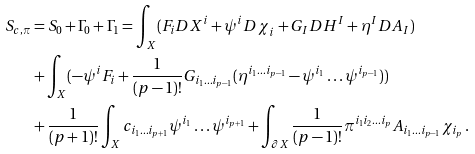<formula> <loc_0><loc_0><loc_500><loc_500>S _ { c , \pi } & = S _ { 0 } + \Gamma _ { 0 } + \Gamma _ { 1 } = \int _ { X } ( { F } _ { i } { D X } ^ { i } + { \psi } ^ { i } { D \chi } _ { i } + { G } _ { I } { D H } ^ { I } + { \eta } ^ { I } { D A } _ { I } ) \\ & + \int _ { X } ( - \psi ^ { i } F _ { i } + \frac { 1 } { ( p - 1 ) ! } G _ { i _ { 1 } \dots i _ { p - 1 } } ( \eta ^ { i _ { 1 } \dots i _ { p - 1 } } - \psi ^ { i _ { 1 } } \dots \psi ^ { i _ { p - 1 } } ) ) \\ & + \frac { 1 } { ( p + 1 ) ! } \int _ { X } c _ { i _ { 1 } \dots i _ { p + 1 } } \psi ^ { i _ { 1 } } \dots \psi ^ { i _ { p + 1 } } + \int _ { \partial X } \frac { 1 } { ( p - 1 ) ! } \pi ^ { i _ { 1 } i _ { 2 } \dots i _ { p } } A _ { i _ { 1 } \dots i _ { p - 1 } } { \chi } _ { i _ { p } } \, .</formula> 